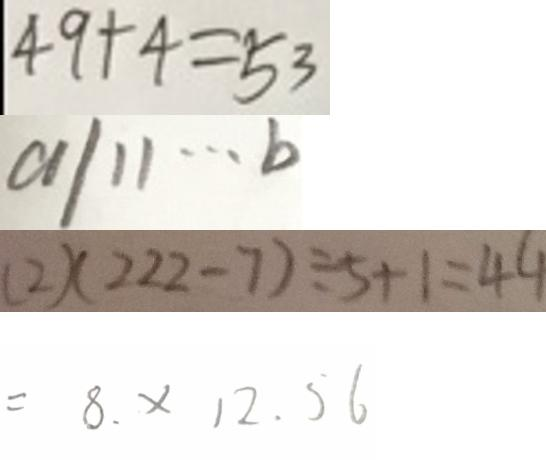<formula> <loc_0><loc_0><loc_500><loc_500>4 9 + 4 = 5 3 
 a / 1 1 \cdots b 
 ( 2 ) ( 2 2 2 - 7 ) \div 5 + 1 = 4 4 
 = 8 . \times 1 2 . 5 6</formula> 